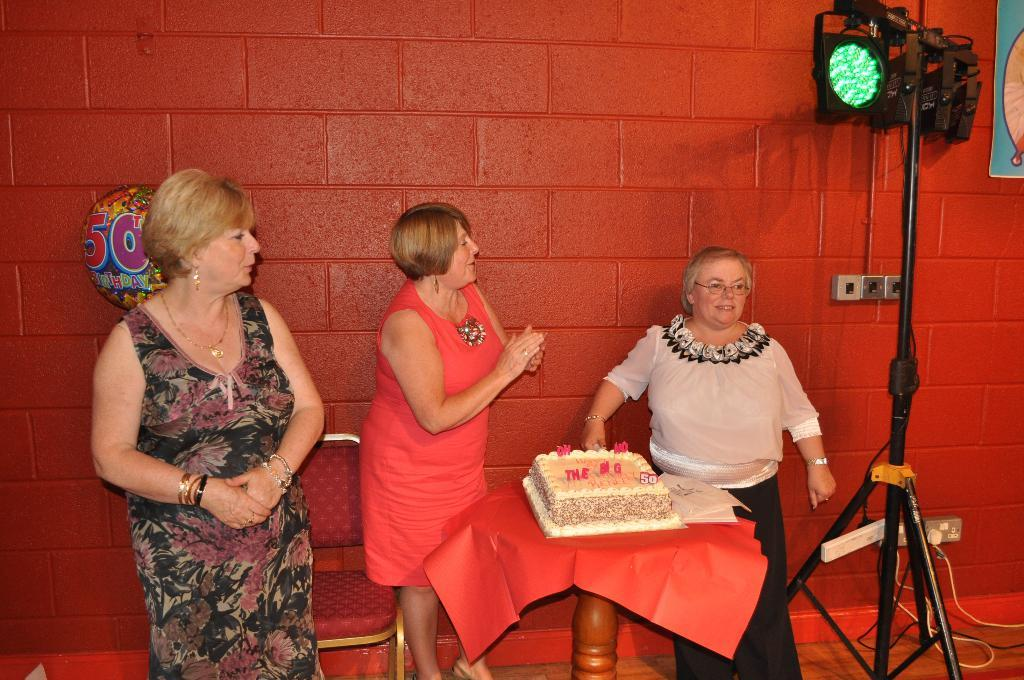How many people are present in the room? There are three people standing in the room. What is located in the room besides the people? There is a table in the room. What is on the table? There is a cake on the table. What can be seen on the wall in the background? There is a red wall with bricks visible in the background. What is visible in the background that provides light? There are lights in the background. What type of property is being discussed in the image? There is no discussion of property in the image; it features three people, a table, a cake, a red wall with bricks, and lights in the background. How does the wound on the person's arm look like in the image? There is no wound visible on any person's arm in the image. 